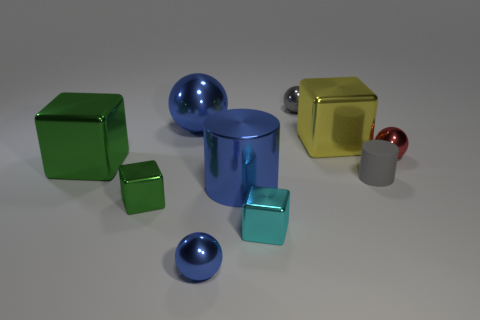Is the metal cylinder the same color as the large metal sphere?
Offer a very short reply. Yes. Does the sphere in front of the tiny green block have the same size as the cylinder to the left of the cyan metallic block?
Your response must be concise. No. The tiny ball that is in front of the red thing is what color?
Offer a terse response. Blue. There is a large blue object that is right of the metal sphere in front of the cyan shiny thing; what is it made of?
Make the answer very short. Metal. What is the shape of the small gray rubber thing?
Ensure brevity in your answer.  Cylinder. How many gray objects are the same size as the cyan metal block?
Your response must be concise. 2. Is there a big blue cylinder to the left of the small gray object that is behind the yellow object?
Keep it short and to the point. Yes. How many brown objects are tiny things or tiny shiny cubes?
Your answer should be compact. 0. The shiny cylinder is what color?
Keep it short and to the point. Blue. What size is the cyan object that is made of the same material as the large yellow block?
Your response must be concise. Small. 